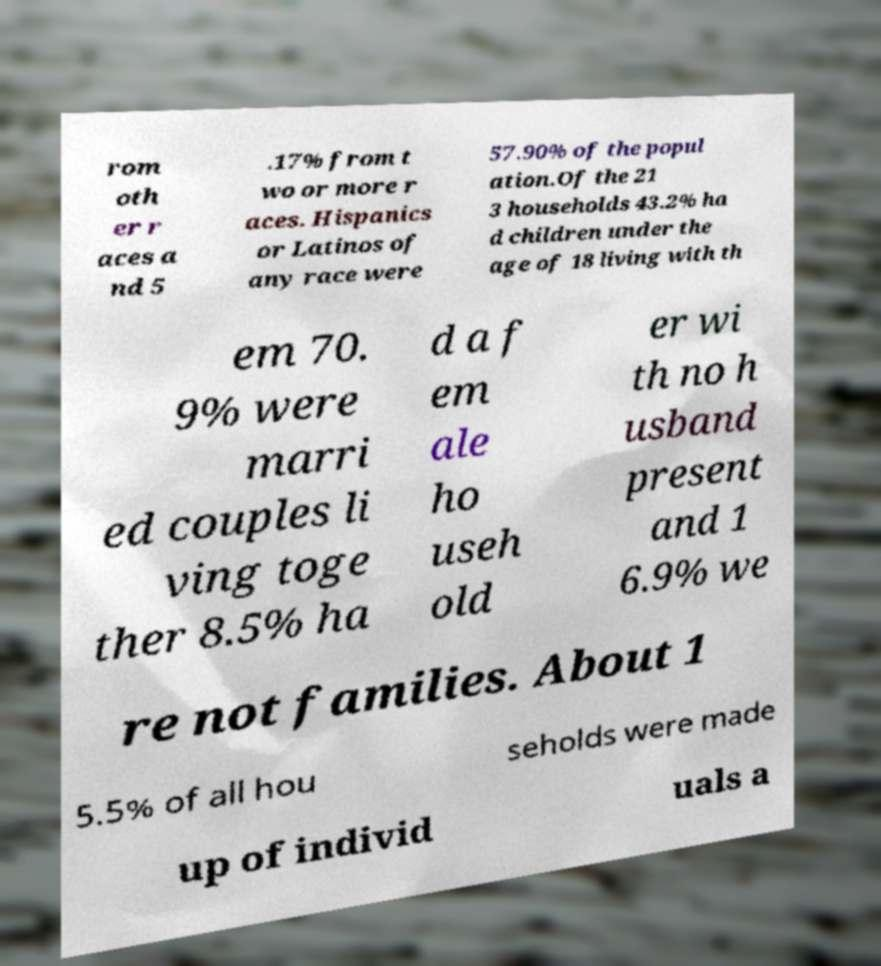Can you read and provide the text displayed in the image?This photo seems to have some interesting text. Can you extract and type it out for me? rom oth er r aces a nd 5 .17% from t wo or more r aces. Hispanics or Latinos of any race were 57.90% of the popul ation.Of the 21 3 households 43.2% ha d children under the age of 18 living with th em 70. 9% were marri ed couples li ving toge ther 8.5% ha d a f em ale ho useh old er wi th no h usband present and 1 6.9% we re not families. About 1 5.5% of all hou seholds were made up of individ uals a 